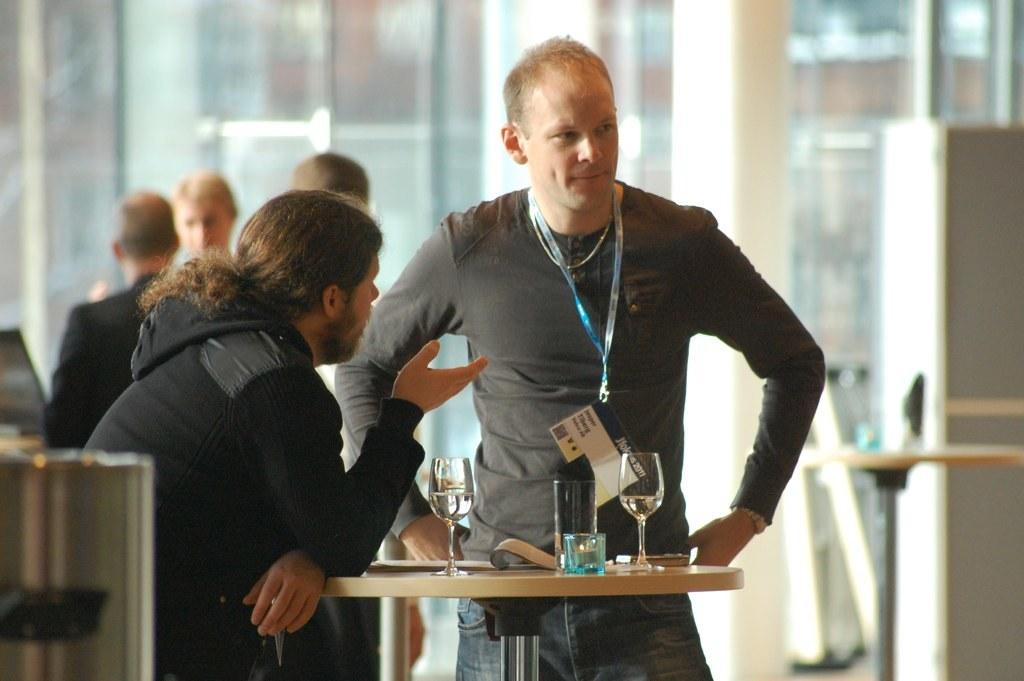How many people are present in the image? There are two people in the image. What are the two people doing in the image? The two people are in front of a table. What can be seen on the table? There are plates on the table. Are there any other people visible in the image? Yes, there are other people visible in the image. What type of grape is being used to fuel the stove in the image? There is no stove or grape present in the image. 